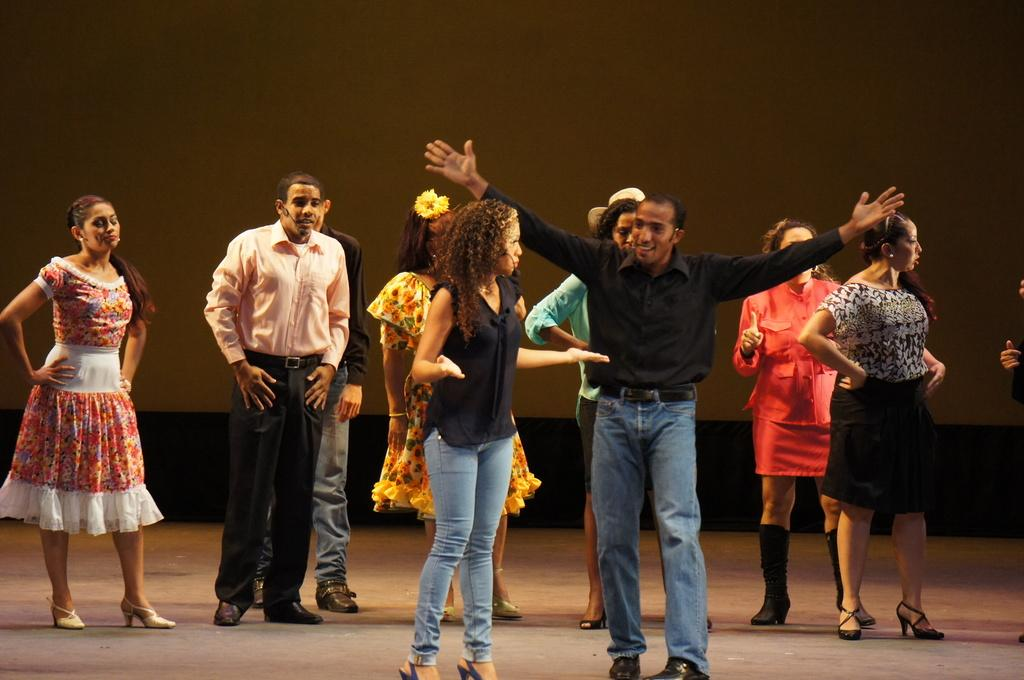Who or what can be seen in the front of the image? There are people in the front of the image. What can be observed about the background of the image? The background of the image is dark. What type of cable is being used by the people in the image? There is no cable visible in the image; it only shows people in the front and a dark background. 